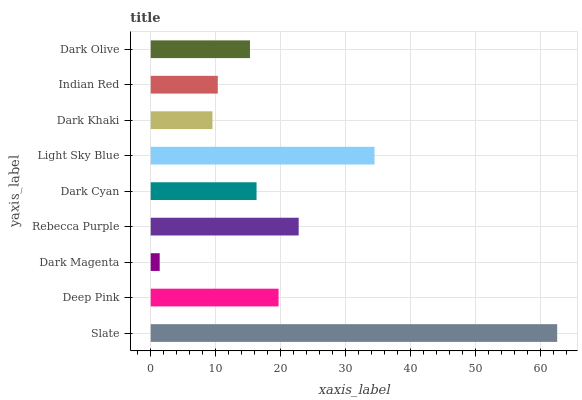Is Dark Magenta the minimum?
Answer yes or no. Yes. Is Slate the maximum?
Answer yes or no. Yes. Is Deep Pink the minimum?
Answer yes or no. No. Is Deep Pink the maximum?
Answer yes or no. No. Is Slate greater than Deep Pink?
Answer yes or no. Yes. Is Deep Pink less than Slate?
Answer yes or no. Yes. Is Deep Pink greater than Slate?
Answer yes or no. No. Is Slate less than Deep Pink?
Answer yes or no. No. Is Dark Cyan the high median?
Answer yes or no. Yes. Is Dark Cyan the low median?
Answer yes or no. Yes. Is Slate the high median?
Answer yes or no. No. Is Dark Khaki the low median?
Answer yes or no. No. 